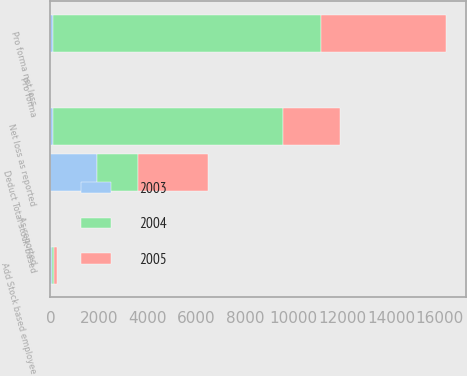Convert chart. <chart><loc_0><loc_0><loc_500><loc_500><stacked_bar_chart><ecel><fcel>Net loss as reported<fcel>Add Stock based employee<fcel>Deduct Total stock-based<fcel>Pro forma net loss<fcel>As reported<fcel>Pro forma<nl><fcel>2003<fcel>100.5<fcel>60<fcel>1919<fcel>100.5<fcel>0.87<fcel>0.95<nl><fcel>2004<fcel>9446<fcel>103<fcel>1690<fcel>11033<fcel>0.45<fcel>0.52<nl><fcel>2005<fcel>2342<fcel>98<fcel>2869<fcel>5113<fcel>0.11<fcel>0.23<nl></chart> 